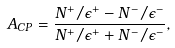<formula> <loc_0><loc_0><loc_500><loc_500>A _ { C P } = \frac { N ^ { + } / \epsilon ^ { + } - N ^ { - } / \epsilon ^ { - } } { N ^ { + } / \epsilon ^ { + } + N ^ { - } / \epsilon ^ { - } } ,</formula> 